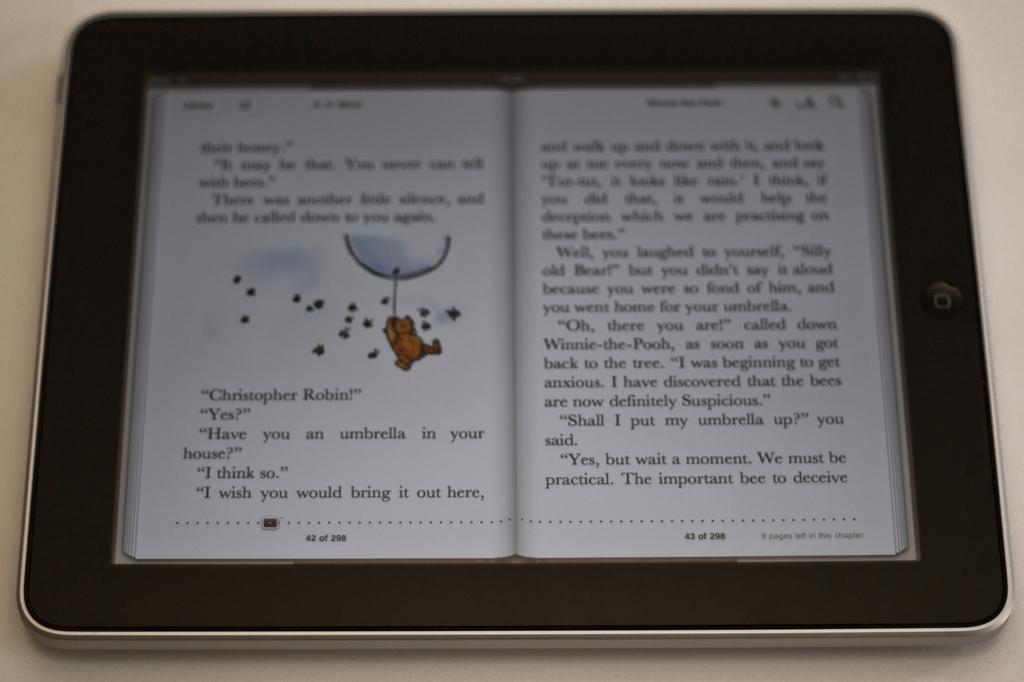What is the name of a character in this ebook?
Ensure brevity in your answer.  Christopher robin. Is this a children's book?
Your answer should be compact. Yes. 